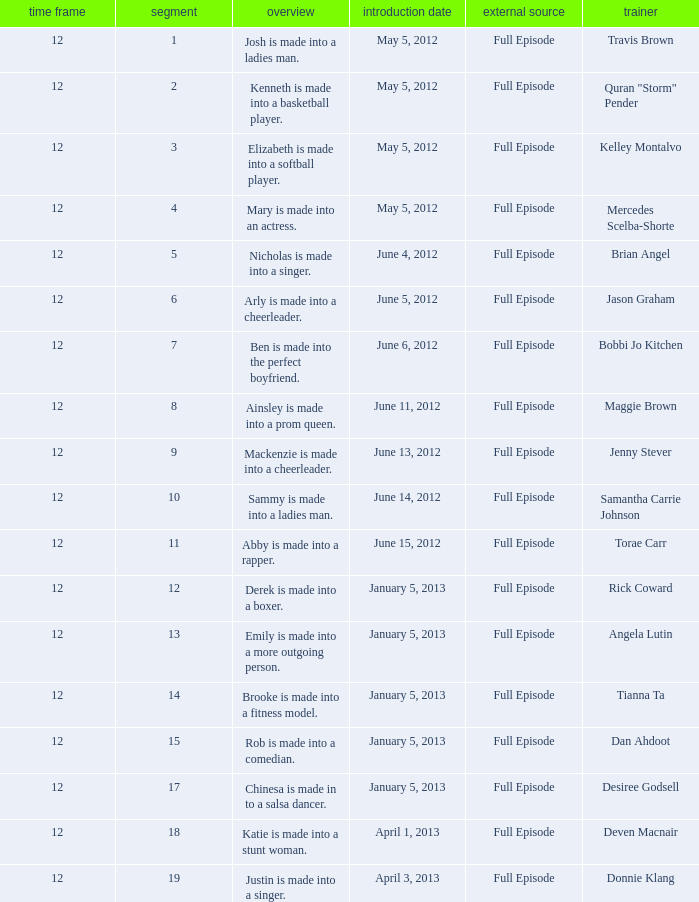Name the least episode for donnie klang 19.0. 